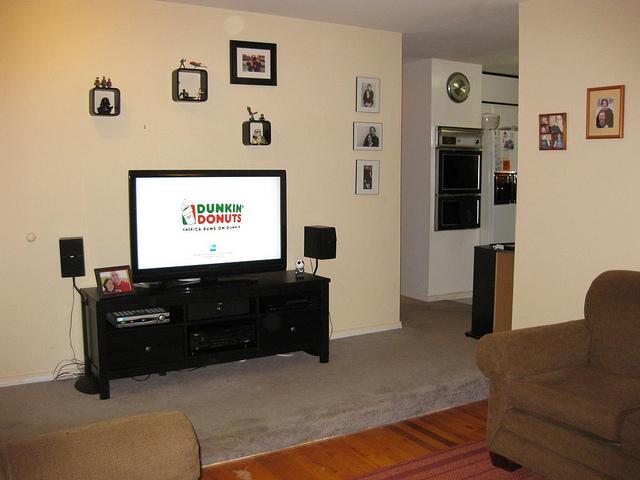How many pictures are on the walls?
Be succinct. 9. Do the inhabitants own pets?
Be succinct. No. Is the oven in the wall?
Answer briefly. Yes. What company logo is on the TV?
Be succinct. Dunkin donuts. What type of product does the company logo sell?
Be succinct. Donuts. 